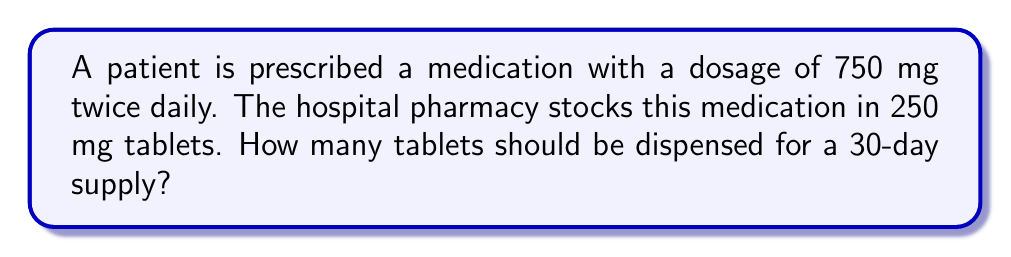Give your solution to this math problem. To solve this problem, we need to follow these steps:

1. Calculate the total daily dosage:
   $750 \text{ mg} \times 2 = 1500 \text{ mg per day}$

2. Determine the number of tablets needed per day:
   $\frac{1500 \text{ mg per day}}{250 \text{ mg per tablet}} = 6 \text{ tablets per day}$

3. Calculate the total number of tablets needed for 30 days:
   $6 \text{ tablets per day} \times 30 \text{ days} = 180 \text{ tablets}$

This calculation is crucial for medical billing specialists to ensure accurate medication dispensing and proper reimbursement. It involves converting between different units of measurement (mg to tablets) and considering the prescription duration.
Answer: 180 tablets 